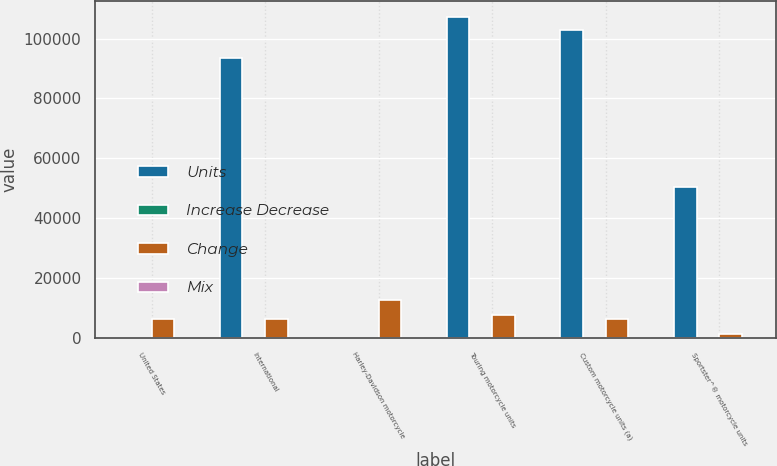Convert chart. <chart><loc_0><loc_0><loc_500><loc_500><stacked_bar_chart><ecel><fcel>United States<fcel>International<fcel>Harley-Davidson motorcycle<fcel>Touring motorcycle units<fcel>Custom motorcycle units (a)<fcel>Sportster^® motorcycle units<nl><fcel>Units<fcel>82.05<fcel>93455<fcel>82.05<fcel>107213<fcel>102950<fcel>50308<nl><fcel>Increase Decrease<fcel>64.1<fcel>35.9<fcel>100<fcel>41.2<fcel>39.5<fcel>19.3<nl><fcel>Change<fcel>6539<fcel>6307<fcel>12846<fcel>7717<fcel>6525<fcel>1396<nl><fcel>Mix<fcel>4.1<fcel>7.2<fcel>5.2<fcel>7.8<fcel>6.8<fcel>2.7<nl></chart> 